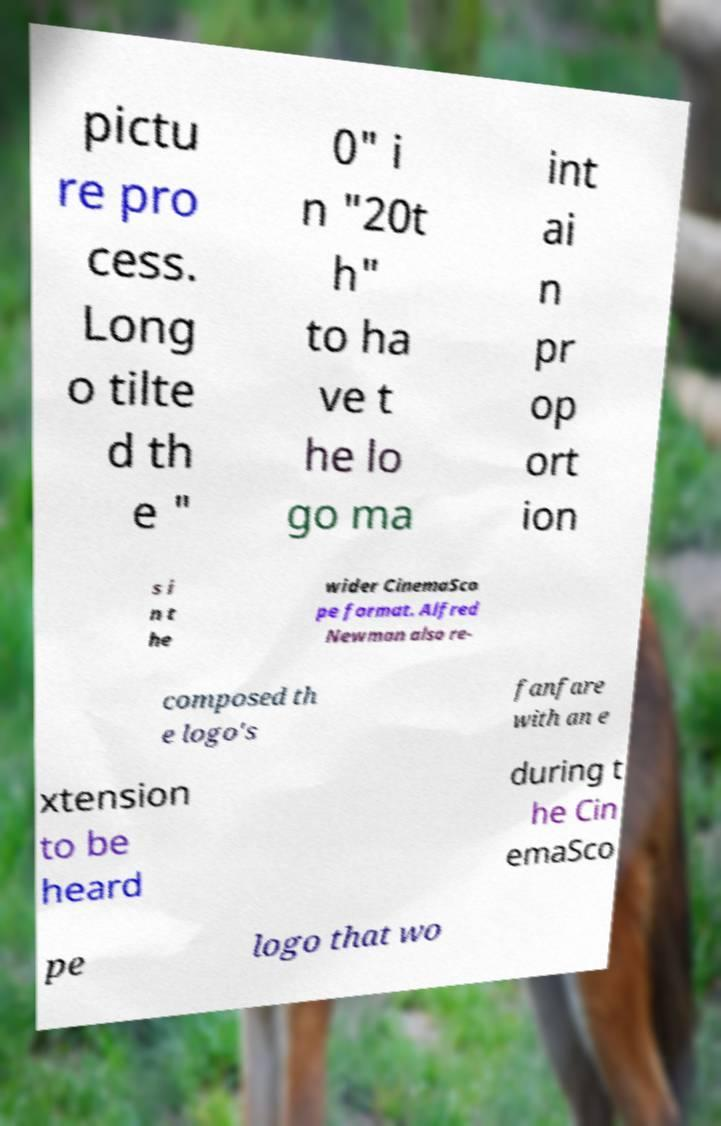What messages or text are displayed in this image? I need them in a readable, typed format. pictu re pro cess. Long o tilte d th e " 0" i n "20t h" to ha ve t he lo go ma int ai n pr op ort ion s i n t he wider CinemaSco pe format. Alfred Newman also re- composed th e logo's fanfare with an e xtension to be heard during t he Cin emaSco pe logo that wo 